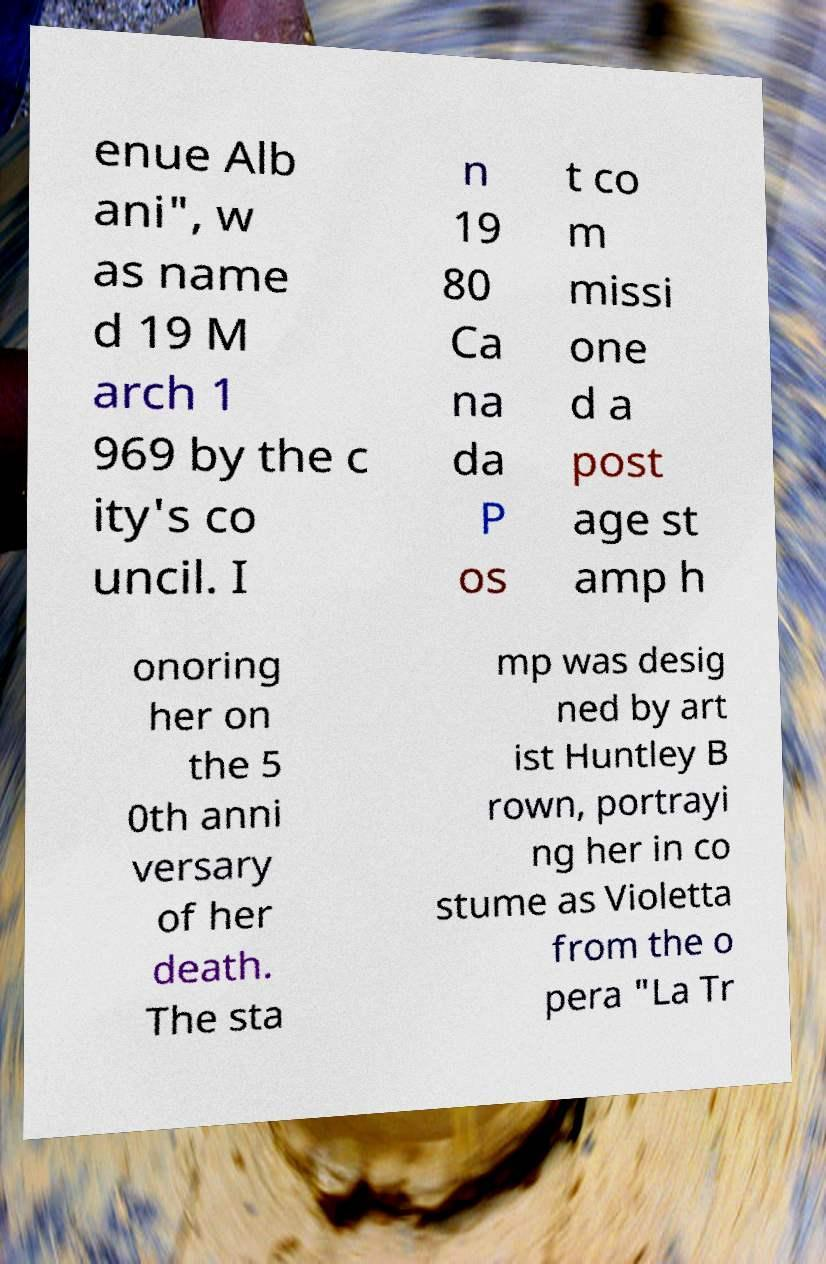Can you read and provide the text displayed in the image?This photo seems to have some interesting text. Can you extract and type it out for me? enue Alb ani", w as name d 19 M arch 1 969 by the c ity's co uncil. I n 19 80 Ca na da P os t co m missi one d a post age st amp h onoring her on the 5 0th anni versary of her death. The sta mp was desig ned by art ist Huntley B rown, portrayi ng her in co stume as Violetta from the o pera "La Tr 